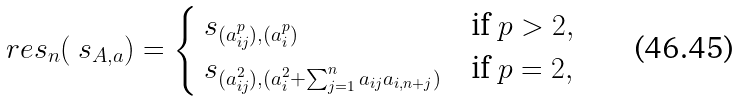Convert formula to latex. <formula><loc_0><loc_0><loc_500><loc_500>\ r e s _ { n } ( \ s _ { A , a } ) = \begin{cases} \ s _ { ( a _ { i j } ^ { p } ) , ( a _ { i } ^ { p } ) } & \text {if $p>2$} , \\ \ s _ { ( a _ { i j } ^ { 2 } ) , ( a _ { i } ^ { 2 } + \sum _ { j = 1 } ^ { n } a _ { i j } a _ { i , n + j } ) } & \text {if $p=2$} , \\ \end{cases}</formula> 